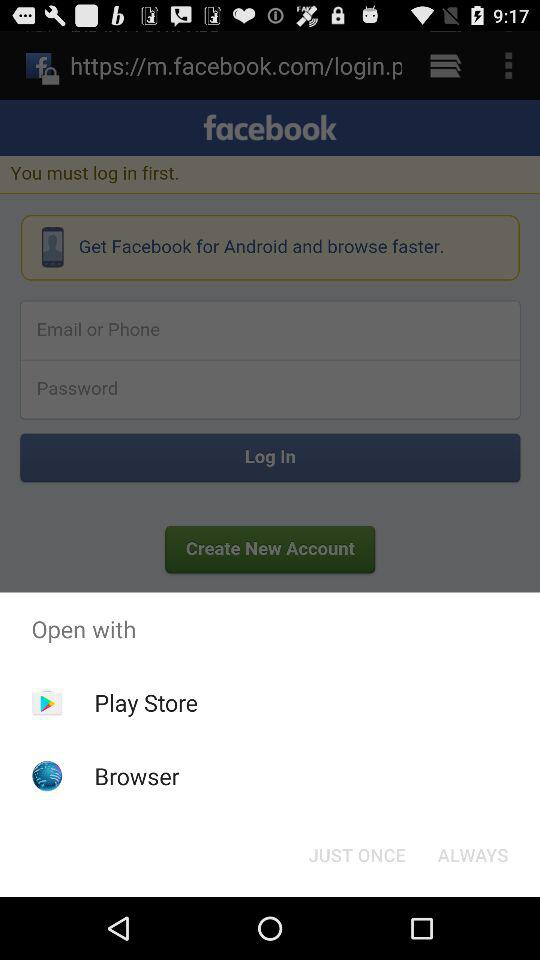What is the entered email address?
When the provided information is insufficient, respond with <no answer>. <no answer> 